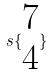<formula> <loc_0><loc_0><loc_500><loc_500>s \{ \begin{matrix} 7 \\ 4 \end{matrix} \}</formula> 